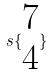<formula> <loc_0><loc_0><loc_500><loc_500>s \{ \begin{matrix} 7 \\ 4 \end{matrix} \}</formula> 